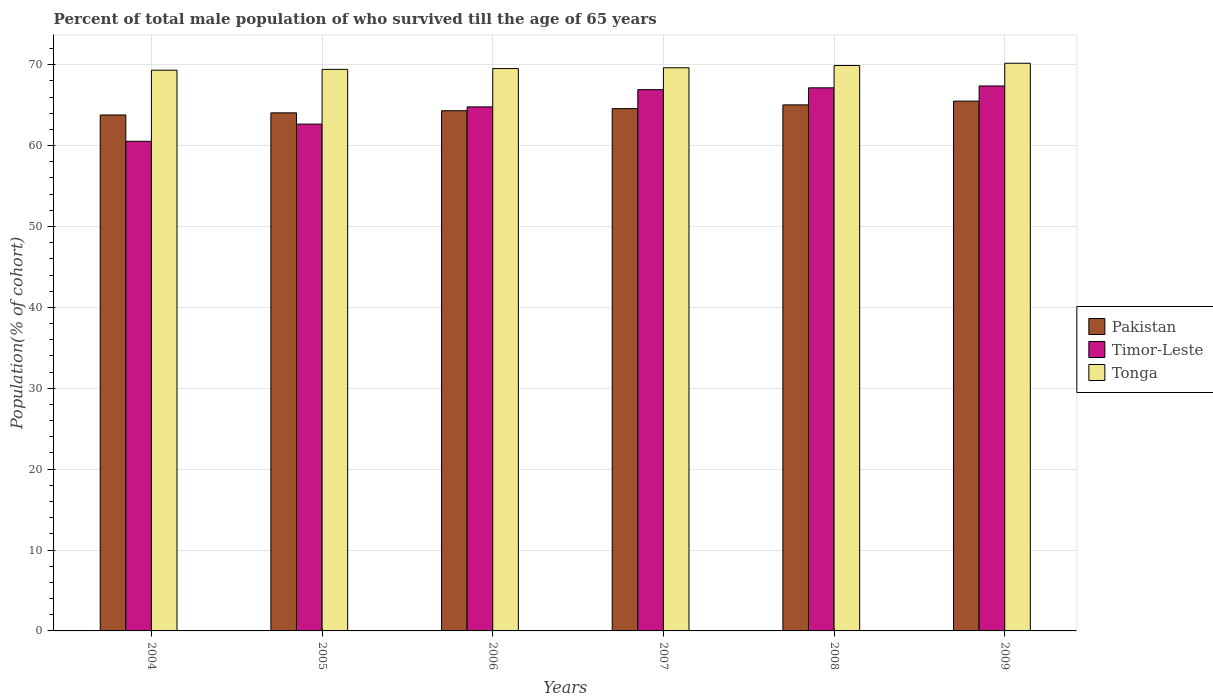How many groups of bars are there?
Your response must be concise. 6. Are the number of bars per tick equal to the number of legend labels?
Offer a very short reply. Yes. Are the number of bars on each tick of the X-axis equal?
Make the answer very short. Yes. How many bars are there on the 3rd tick from the left?
Your answer should be very brief. 3. How many bars are there on the 4th tick from the right?
Provide a succinct answer. 3. In how many cases, is the number of bars for a given year not equal to the number of legend labels?
Make the answer very short. 0. What is the percentage of total male population who survived till the age of 65 years in Tonga in 2008?
Make the answer very short. 69.91. Across all years, what is the maximum percentage of total male population who survived till the age of 65 years in Pakistan?
Provide a short and direct response. 65.51. Across all years, what is the minimum percentage of total male population who survived till the age of 65 years in Pakistan?
Provide a succinct answer. 63.79. In which year was the percentage of total male population who survived till the age of 65 years in Tonga minimum?
Your answer should be very brief. 2004. What is the total percentage of total male population who survived till the age of 65 years in Pakistan in the graph?
Your response must be concise. 387.29. What is the difference between the percentage of total male population who survived till the age of 65 years in Timor-Leste in 2006 and that in 2009?
Give a very brief answer. -2.58. What is the difference between the percentage of total male population who survived till the age of 65 years in Timor-Leste in 2008 and the percentage of total male population who survived till the age of 65 years in Pakistan in 2005?
Ensure brevity in your answer.  3.09. What is the average percentage of total male population who survived till the age of 65 years in Tonga per year?
Provide a short and direct response. 69.67. In the year 2007, what is the difference between the percentage of total male population who survived till the age of 65 years in Pakistan and percentage of total male population who survived till the age of 65 years in Timor-Leste?
Offer a very short reply. -2.34. What is the ratio of the percentage of total male population who survived till the age of 65 years in Pakistan in 2006 to that in 2009?
Keep it short and to the point. 0.98. Is the percentage of total male population who survived till the age of 65 years in Timor-Leste in 2004 less than that in 2007?
Ensure brevity in your answer.  Yes. Is the difference between the percentage of total male population who survived till the age of 65 years in Pakistan in 2007 and 2009 greater than the difference between the percentage of total male population who survived till the age of 65 years in Timor-Leste in 2007 and 2009?
Offer a terse response. No. What is the difference between the highest and the second highest percentage of total male population who survived till the age of 65 years in Timor-Leste?
Provide a succinct answer. 0.23. What is the difference between the highest and the lowest percentage of total male population who survived till the age of 65 years in Timor-Leste?
Offer a terse response. 6.84. In how many years, is the percentage of total male population who survived till the age of 65 years in Timor-Leste greater than the average percentage of total male population who survived till the age of 65 years in Timor-Leste taken over all years?
Keep it short and to the point. 3. Is the sum of the percentage of total male population who survived till the age of 65 years in Timor-Leste in 2007 and 2009 greater than the maximum percentage of total male population who survived till the age of 65 years in Tonga across all years?
Provide a short and direct response. Yes. What does the 3rd bar from the left in 2004 represents?
Provide a succinct answer. Tonga. What does the 2nd bar from the right in 2006 represents?
Offer a very short reply. Timor-Leste. How many bars are there?
Offer a terse response. 18. Are all the bars in the graph horizontal?
Provide a succinct answer. No. How many years are there in the graph?
Ensure brevity in your answer.  6. What is the difference between two consecutive major ticks on the Y-axis?
Provide a succinct answer. 10. Are the values on the major ticks of Y-axis written in scientific E-notation?
Your response must be concise. No. Does the graph contain grids?
Offer a very short reply. Yes. What is the title of the graph?
Make the answer very short. Percent of total male population of who survived till the age of 65 years. What is the label or title of the Y-axis?
Your response must be concise. Population(% of cohort). What is the Population(% of cohort) in Pakistan in 2004?
Keep it short and to the point. 63.79. What is the Population(% of cohort) in Timor-Leste in 2004?
Ensure brevity in your answer.  60.53. What is the Population(% of cohort) of Tonga in 2004?
Give a very brief answer. 69.33. What is the Population(% of cohort) of Pakistan in 2005?
Make the answer very short. 64.05. What is the Population(% of cohort) in Timor-Leste in 2005?
Your answer should be compact. 62.66. What is the Population(% of cohort) of Tonga in 2005?
Provide a short and direct response. 69.43. What is the Population(% of cohort) in Pakistan in 2006?
Your answer should be compact. 64.32. What is the Population(% of cohort) of Timor-Leste in 2006?
Ensure brevity in your answer.  64.79. What is the Population(% of cohort) of Tonga in 2006?
Offer a terse response. 69.53. What is the Population(% of cohort) of Pakistan in 2007?
Offer a terse response. 64.58. What is the Population(% of cohort) of Timor-Leste in 2007?
Offer a very short reply. 66.92. What is the Population(% of cohort) of Tonga in 2007?
Offer a terse response. 69.63. What is the Population(% of cohort) of Pakistan in 2008?
Your answer should be very brief. 65.04. What is the Population(% of cohort) in Timor-Leste in 2008?
Ensure brevity in your answer.  67.15. What is the Population(% of cohort) in Tonga in 2008?
Offer a very short reply. 69.91. What is the Population(% of cohort) in Pakistan in 2009?
Your answer should be compact. 65.51. What is the Population(% of cohort) of Timor-Leste in 2009?
Make the answer very short. 67.38. What is the Population(% of cohort) in Tonga in 2009?
Your answer should be very brief. 70.19. Across all years, what is the maximum Population(% of cohort) in Pakistan?
Keep it short and to the point. 65.51. Across all years, what is the maximum Population(% of cohort) of Timor-Leste?
Provide a short and direct response. 67.38. Across all years, what is the maximum Population(% of cohort) in Tonga?
Provide a succinct answer. 70.19. Across all years, what is the minimum Population(% of cohort) in Pakistan?
Give a very brief answer. 63.79. Across all years, what is the minimum Population(% of cohort) of Timor-Leste?
Ensure brevity in your answer.  60.53. Across all years, what is the minimum Population(% of cohort) in Tonga?
Your response must be concise. 69.33. What is the total Population(% of cohort) in Pakistan in the graph?
Make the answer very short. 387.29. What is the total Population(% of cohort) of Timor-Leste in the graph?
Make the answer very short. 389.44. What is the total Population(% of cohort) in Tonga in the graph?
Provide a succinct answer. 418.02. What is the difference between the Population(% of cohort) in Pakistan in 2004 and that in 2005?
Offer a very short reply. -0.26. What is the difference between the Population(% of cohort) in Timor-Leste in 2004 and that in 2005?
Make the answer very short. -2.13. What is the difference between the Population(% of cohort) in Tonga in 2004 and that in 2005?
Keep it short and to the point. -0.1. What is the difference between the Population(% of cohort) in Pakistan in 2004 and that in 2006?
Your answer should be compact. -0.52. What is the difference between the Population(% of cohort) of Timor-Leste in 2004 and that in 2006?
Your answer should be compact. -4.26. What is the difference between the Population(% of cohort) of Tonga in 2004 and that in 2006?
Provide a succinct answer. -0.2. What is the difference between the Population(% of cohort) in Pakistan in 2004 and that in 2007?
Your answer should be compact. -0.79. What is the difference between the Population(% of cohort) in Timor-Leste in 2004 and that in 2007?
Your answer should be compact. -6.39. What is the difference between the Population(% of cohort) in Tonga in 2004 and that in 2007?
Make the answer very short. -0.29. What is the difference between the Population(% of cohort) of Pakistan in 2004 and that in 2008?
Make the answer very short. -1.25. What is the difference between the Population(% of cohort) of Timor-Leste in 2004 and that in 2008?
Make the answer very short. -6.61. What is the difference between the Population(% of cohort) in Tonga in 2004 and that in 2008?
Make the answer very short. -0.57. What is the difference between the Population(% of cohort) of Pakistan in 2004 and that in 2009?
Keep it short and to the point. -1.71. What is the difference between the Population(% of cohort) of Timor-Leste in 2004 and that in 2009?
Provide a succinct answer. -6.84. What is the difference between the Population(% of cohort) of Tonga in 2004 and that in 2009?
Keep it short and to the point. -0.85. What is the difference between the Population(% of cohort) of Pakistan in 2005 and that in 2006?
Ensure brevity in your answer.  -0.26. What is the difference between the Population(% of cohort) of Timor-Leste in 2005 and that in 2006?
Your answer should be very brief. -2.13. What is the difference between the Population(% of cohort) in Tonga in 2005 and that in 2006?
Ensure brevity in your answer.  -0.1. What is the difference between the Population(% of cohort) of Pakistan in 2005 and that in 2007?
Keep it short and to the point. -0.52. What is the difference between the Population(% of cohort) in Timor-Leste in 2005 and that in 2007?
Give a very brief answer. -4.26. What is the difference between the Population(% of cohort) in Tonga in 2005 and that in 2007?
Give a very brief answer. -0.2. What is the difference between the Population(% of cohort) in Pakistan in 2005 and that in 2008?
Ensure brevity in your answer.  -0.99. What is the difference between the Population(% of cohort) of Timor-Leste in 2005 and that in 2008?
Ensure brevity in your answer.  -4.49. What is the difference between the Population(% of cohort) in Tonga in 2005 and that in 2008?
Provide a short and direct response. -0.48. What is the difference between the Population(% of cohort) of Pakistan in 2005 and that in 2009?
Your answer should be very brief. -1.45. What is the difference between the Population(% of cohort) in Timor-Leste in 2005 and that in 2009?
Offer a very short reply. -4.71. What is the difference between the Population(% of cohort) of Tonga in 2005 and that in 2009?
Offer a terse response. -0.75. What is the difference between the Population(% of cohort) of Pakistan in 2006 and that in 2007?
Offer a very short reply. -0.26. What is the difference between the Population(% of cohort) in Timor-Leste in 2006 and that in 2007?
Your answer should be very brief. -2.13. What is the difference between the Population(% of cohort) of Tonga in 2006 and that in 2007?
Your answer should be very brief. -0.1. What is the difference between the Population(% of cohort) of Pakistan in 2006 and that in 2008?
Offer a very short reply. -0.73. What is the difference between the Population(% of cohort) of Timor-Leste in 2006 and that in 2008?
Make the answer very short. -2.36. What is the difference between the Population(% of cohort) in Tonga in 2006 and that in 2008?
Make the answer very short. -0.38. What is the difference between the Population(% of cohort) in Pakistan in 2006 and that in 2009?
Provide a succinct answer. -1.19. What is the difference between the Population(% of cohort) of Timor-Leste in 2006 and that in 2009?
Give a very brief answer. -2.58. What is the difference between the Population(% of cohort) of Tonga in 2006 and that in 2009?
Your response must be concise. -0.66. What is the difference between the Population(% of cohort) of Pakistan in 2007 and that in 2008?
Your response must be concise. -0.46. What is the difference between the Population(% of cohort) in Timor-Leste in 2007 and that in 2008?
Provide a short and direct response. -0.23. What is the difference between the Population(% of cohort) of Tonga in 2007 and that in 2008?
Make the answer very short. -0.28. What is the difference between the Population(% of cohort) in Pakistan in 2007 and that in 2009?
Offer a very short reply. -0.93. What is the difference between the Population(% of cohort) of Timor-Leste in 2007 and that in 2009?
Offer a terse response. -0.46. What is the difference between the Population(% of cohort) in Tonga in 2007 and that in 2009?
Your answer should be very brief. -0.56. What is the difference between the Population(% of cohort) in Pakistan in 2008 and that in 2009?
Keep it short and to the point. -0.46. What is the difference between the Population(% of cohort) in Timor-Leste in 2008 and that in 2009?
Give a very brief answer. -0.23. What is the difference between the Population(% of cohort) of Tonga in 2008 and that in 2009?
Ensure brevity in your answer.  -0.28. What is the difference between the Population(% of cohort) in Pakistan in 2004 and the Population(% of cohort) in Timor-Leste in 2005?
Provide a succinct answer. 1.13. What is the difference between the Population(% of cohort) in Pakistan in 2004 and the Population(% of cohort) in Tonga in 2005?
Keep it short and to the point. -5.64. What is the difference between the Population(% of cohort) of Timor-Leste in 2004 and the Population(% of cohort) of Tonga in 2005?
Make the answer very short. -8.9. What is the difference between the Population(% of cohort) in Pakistan in 2004 and the Population(% of cohort) in Timor-Leste in 2006?
Keep it short and to the point. -1. What is the difference between the Population(% of cohort) of Pakistan in 2004 and the Population(% of cohort) of Tonga in 2006?
Make the answer very short. -5.74. What is the difference between the Population(% of cohort) of Timor-Leste in 2004 and the Population(% of cohort) of Tonga in 2006?
Your answer should be very brief. -8.99. What is the difference between the Population(% of cohort) in Pakistan in 2004 and the Population(% of cohort) in Timor-Leste in 2007?
Keep it short and to the point. -3.13. What is the difference between the Population(% of cohort) in Pakistan in 2004 and the Population(% of cohort) in Tonga in 2007?
Offer a very short reply. -5.83. What is the difference between the Population(% of cohort) in Timor-Leste in 2004 and the Population(% of cohort) in Tonga in 2007?
Your answer should be very brief. -9.09. What is the difference between the Population(% of cohort) of Pakistan in 2004 and the Population(% of cohort) of Timor-Leste in 2008?
Provide a succinct answer. -3.36. What is the difference between the Population(% of cohort) in Pakistan in 2004 and the Population(% of cohort) in Tonga in 2008?
Your answer should be very brief. -6.11. What is the difference between the Population(% of cohort) in Timor-Leste in 2004 and the Population(% of cohort) in Tonga in 2008?
Offer a terse response. -9.37. What is the difference between the Population(% of cohort) in Pakistan in 2004 and the Population(% of cohort) in Timor-Leste in 2009?
Keep it short and to the point. -3.58. What is the difference between the Population(% of cohort) in Pakistan in 2004 and the Population(% of cohort) in Tonga in 2009?
Provide a short and direct response. -6.39. What is the difference between the Population(% of cohort) of Timor-Leste in 2004 and the Population(% of cohort) of Tonga in 2009?
Your response must be concise. -9.65. What is the difference between the Population(% of cohort) of Pakistan in 2005 and the Population(% of cohort) of Timor-Leste in 2006?
Keep it short and to the point. -0.74. What is the difference between the Population(% of cohort) of Pakistan in 2005 and the Population(% of cohort) of Tonga in 2006?
Your answer should be compact. -5.47. What is the difference between the Population(% of cohort) in Timor-Leste in 2005 and the Population(% of cohort) in Tonga in 2006?
Give a very brief answer. -6.87. What is the difference between the Population(% of cohort) of Pakistan in 2005 and the Population(% of cohort) of Timor-Leste in 2007?
Give a very brief answer. -2.87. What is the difference between the Population(% of cohort) in Pakistan in 2005 and the Population(% of cohort) in Tonga in 2007?
Give a very brief answer. -5.57. What is the difference between the Population(% of cohort) of Timor-Leste in 2005 and the Population(% of cohort) of Tonga in 2007?
Make the answer very short. -6.96. What is the difference between the Population(% of cohort) of Pakistan in 2005 and the Population(% of cohort) of Timor-Leste in 2008?
Make the answer very short. -3.09. What is the difference between the Population(% of cohort) in Pakistan in 2005 and the Population(% of cohort) in Tonga in 2008?
Your answer should be very brief. -5.85. What is the difference between the Population(% of cohort) of Timor-Leste in 2005 and the Population(% of cohort) of Tonga in 2008?
Your response must be concise. -7.24. What is the difference between the Population(% of cohort) of Pakistan in 2005 and the Population(% of cohort) of Timor-Leste in 2009?
Make the answer very short. -3.32. What is the difference between the Population(% of cohort) in Pakistan in 2005 and the Population(% of cohort) in Tonga in 2009?
Your response must be concise. -6.13. What is the difference between the Population(% of cohort) in Timor-Leste in 2005 and the Population(% of cohort) in Tonga in 2009?
Offer a very short reply. -7.52. What is the difference between the Population(% of cohort) of Pakistan in 2006 and the Population(% of cohort) of Timor-Leste in 2007?
Give a very brief answer. -2.6. What is the difference between the Population(% of cohort) of Pakistan in 2006 and the Population(% of cohort) of Tonga in 2007?
Your response must be concise. -5.31. What is the difference between the Population(% of cohort) in Timor-Leste in 2006 and the Population(% of cohort) in Tonga in 2007?
Your answer should be compact. -4.84. What is the difference between the Population(% of cohort) in Pakistan in 2006 and the Population(% of cohort) in Timor-Leste in 2008?
Make the answer very short. -2.83. What is the difference between the Population(% of cohort) of Pakistan in 2006 and the Population(% of cohort) of Tonga in 2008?
Your response must be concise. -5.59. What is the difference between the Population(% of cohort) in Timor-Leste in 2006 and the Population(% of cohort) in Tonga in 2008?
Your response must be concise. -5.11. What is the difference between the Population(% of cohort) of Pakistan in 2006 and the Population(% of cohort) of Timor-Leste in 2009?
Keep it short and to the point. -3.06. What is the difference between the Population(% of cohort) of Pakistan in 2006 and the Population(% of cohort) of Tonga in 2009?
Give a very brief answer. -5.87. What is the difference between the Population(% of cohort) of Timor-Leste in 2006 and the Population(% of cohort) of Tonga in 2009?
Give a very brief answer. -5.39. What is the difference between the Population(% of cohort) in Pakistan in 2007 and the Population(% of cohort) in Timor-Leste in 2008?
Your answer should be compact. -2.57. What is the difference between the Population(% of cohort) of Pakistan in 2007 and the Population(% of cohort) of Tonga in 2008?
Provide a short and direct response. -5.33. What is the difference between the Population(% of cohort) of Timor-Leste in 2007 and the Population(% of cohort) of Tonga in 2008?
Your answer should be very brief. -2.99. What is the difference between the Population(% of cohort) in Pakistan in 2007 and the Population(% of cohort) in Timor-Leste in 2009?
Make the answer very short. -2.8. What is the difference between the Population(% of cohort) in Pakistan in 2007 and the Population(% of cohort) in Tonga in 2009?
Make the answer very short. -5.61. What is the difference between the Population(% of cohort) of Timor-Leste in 2007 and the Population(% of cohort) of Tonga in 2009?
Make the answer very short. -3.27. What is the difference between the Population(% of cohort) of Pakistan in 2008 and the Population(% of cohort) of Timor-Leste in 2009?
Provide a short and direct response. -2.33. What is the difference between the Population(% of cohort) in Pakistan in 2008 and the Population(% of cohort) in Tonga in 2009?
Offer a terse response. -5.14. What is the difference between the Population(% of cohort) of Timor-Leste in 2008 and the Population(% of cohort) of Tonga in 2009?
Offer a very short reply. -3.04. What is the average Population(% of cohort) in Pakistan per year?
Keep it short and to the point. 64.55. What is the average Population(% of cohort) of Timor-Leste per year?
Offer a terse response. 64.91. What is the average Population(% of cohort) of Tonga per year?
Your response must be concise. 69.67. In the year 2004, what is the difference between the Population(% of cohort) in Pakistan and Population(% of cohort) in Timor-Leste?
Keep it short and to the point. 3.26. In the year 2004, what is the difference between the Population(% of cohort) in Pakistan and Population(% of cohort) in Tonga?
Give a very brief answer. -5.54. In the year 2004, what is the difference between the Population(% of cohort) of Timor-Leste and Population(% of cohort) of Tonga?
Make the answer very short. -8.8. In the year 2005, what is the difference between the Population(% of cohort) in Pakistan and Population(% of cohort) in Timor-Leste?
Offer a very short reply. 1.39. In the year 2005, what is the difference between the Population(% of cohort) in Pakistan and Population(% of cohort) in Tonga?
Give a very brief answer. -5.38. In the year 2005, what is the difference between the Population(% of cohort) of Timor-Leste and Population(% of cohort) of Tonga?
Give a very brief answer. -6.77. In the year 2006, what is the difference between the Population(% of cohort) in Pakistan and Population(% of cohort) in Timor-Leste?
Offer a very short reply. -0.48. In the year 2006, what is the difference between the Population(% of cohort) in Pakistan and Population(% of cohort) in Tonga?
Offer a very short reply. -5.21. In the year 2006, what is the difference between the Population(% of cohort) in Timor-Leste and Population(% of cohort) in Tonga?
Offer a terse response. -4.74. In the year 2007, what is the difference between the Population(% of cohort) of Pakistan and Population(% of cohort) of Timor-Leste?
Give a very brief answer. -2.34. In the year 2007, what is the difference between the Population(% of cohort) in Pakistan and Population(% of cohort) in Tonga?
Provide a succinct answer. -5.05. In the year 2007, what is the difference between the Population(% of cohort) of Timor-Leste and Population(% of cohort) of Tonga?
Your answer should be very brief. -2.71. In the year 2008, what is the difference between the Population(% of cohort) of Pakistan and Population(% of cohort) of Timor-Leste?
Ensure brevity in your answer.  -2.11. In the year 2008, what is the difference between the Population(% of cohort) in Pakistan and Population(% of cohort) in Tonga?
Ensure brevity in your answer.  -4.86. In the year 2008, what is the difference between the Population(% of cohort) in Timor-Leste and Population(% of cohort) in Tonga?
Keep it short and to the point. -2.76. In the year 2009, what is the difference between the Population(% of cohort) in Pakistan and Population(% of cohort) in Timor-Leste?
Give a very brief answer. -1.87. In the year 2009, what is the difference between the Population(% of cohort) in Pakistan and Population(% of cohort) in Tonga?
Provide a succinct answer. -4.68. In the year 2009, what is the difference between the Population(% of cohort) of Timor-Leste and Population(% of cohort) of Tonga?
Your answer should be compact. -2.81. What is the ratio of the Population(% of cohort) in Timor-Leste in 2004 to that in 2005?
Offer a terse response. 0.97. What is the ratio of the Population(% of cohort) of Timor-Leste in 2004 to that in 2006?
Keep it short and to the point. 0.93. What is the ratio of the Population(% of cohort) in Timor-Leste in 2004 to that in 2007?
Offer a very short reply. 0.9. What is the ratio of the Population(% of cohort) in Pakistan in 2004 to that in 2008?
Your answer should be compact. 0.98. What is the ratio of the Population(% of cohort) of Timor-Leste in 2004 to that in 2008?
Provide a succinct answer. 0.9. What is the ratio of the Population(% of cohort) of Tonga in 2004 to that in 2008?
Offer a very short reply. 0.99. What is the ratio of the Population(% of cohort) in Pakistan in 2004 to that in 2009?
Make the answer very short. 0.97. What is the ratio of the Population(% of cohort) in Timor-Leste in 2004 to that in 2009?
Your answer should be very brief. 0.9. What is the ratio of the Population(% of cohort) of Pakistan in 2005 to that in 2006?
Your answer should be very brief. 1. What is the ratio of the Population(% of cohort) of Timor-Leste in 2005 to that in 2006?
Your answer should be very brief. 0.97. What is the ratio of the Population(% of cohort) in Timor-Leste in 2005 to that in 2007?
Ensure brevity in your answer.  0.94. What is the ratio of the Population(% of cohort) in Timor-Leste in 2005 to that in 2008?
Keep it short and to the point. 0.93. What is the ratio of the Population(% of cohort) in Pakistan in 2005 to that in 2009?
Ensure brevity in your answer.  0.98. What is the ratio of the Population(% of cohort) of Timor-Leste in 2006 to that in 2007?
Your response must be concise. 0.97. What is the ratio of the Population(% of cohort) in Pakistan in 2006 to that in 2008?
Make the answer very short. 0.99. What is the ratio of the Population(% of cohort) in Timor-Leste in 2006 to that in 2008?
Provide a short and direct response. 0.96. What is the ratio of the Population(% of cohort) in Pakistan in 2006 to that in 2009?
Offer a terse response. 0.98. What is the ratio of the Population(% of cohort) in Timor-Leste in 2006 to that in 2009?
Ensure brevity in your answer.  0.96. What is the ratio of the Population(% of cohort) in Tonga in 2006 to that in 2009?
Offer a terse response. 0.99. What is the ratio of the Population(% of cohort) of Pakistan in 2007 to that in 2008?
Offer a terse response. 0.99. What is the ratio of the Population(% of cohort) of Timor-Leste in 2007 to that in 2008?
Your response must be concise. 1. What is the ratio of the Population(% of cohort) in Tonga in 2007 to that in 2008?
Your answer should be compact. 1. What is the ratio of the Population(% of cohort) in Pakistan in 2007 to that in 2009?
Keep it short and to the point. 0.99. What is the ratio of the Population(% of cohort) in Timor-Leste in 2007 to that in 2009?
Offer a very short reply. 0.99. What is the ratio of the Population(% of cohort) of Tonga in 2007 to that in 2009?
Offer a terse response. 0.99. What is the ratio of the Population(% of cohort) in Pakistan in 2008 to that in 2009?
Your answer should be compact. 0.99. What is the difference between the highest and the second highest Population(% of cohort) of Pakistan?
Ensure brevity in your answer.  0.46. What is the difference between the highest and the second highest Population(% of cohort) in Timor-Leste?
Your answer should be compact. 0.23. What is the difference between the highest and the second highest Population(% of cohort) in Tonga?
Your answer should be compact. 0.28. What is the difference between the highest and the lowest Population(% of cohort) in Pakistan?
Offer a terse response. 1.71. What is the difference between the highest and the lowest Population(% of cohort) of Timor-Leste?
Give a very brief answer. 6.84. What is the difference between the highest and the lowest Population(% of cohort) of Tonga?
Make the answer very short. 0.85. 